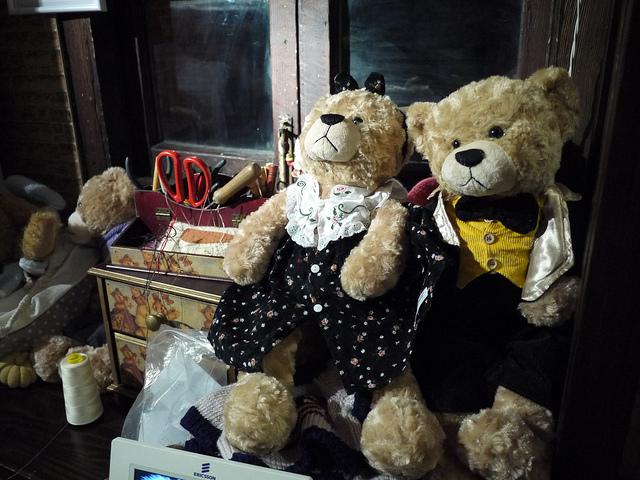What pattern is printed on the front of the drawer?
Concise answer only. Bears. How many bears are there in the picture?
Short answer required. 3. Are the bears wearing clothes?
Be succinct. Yes. 